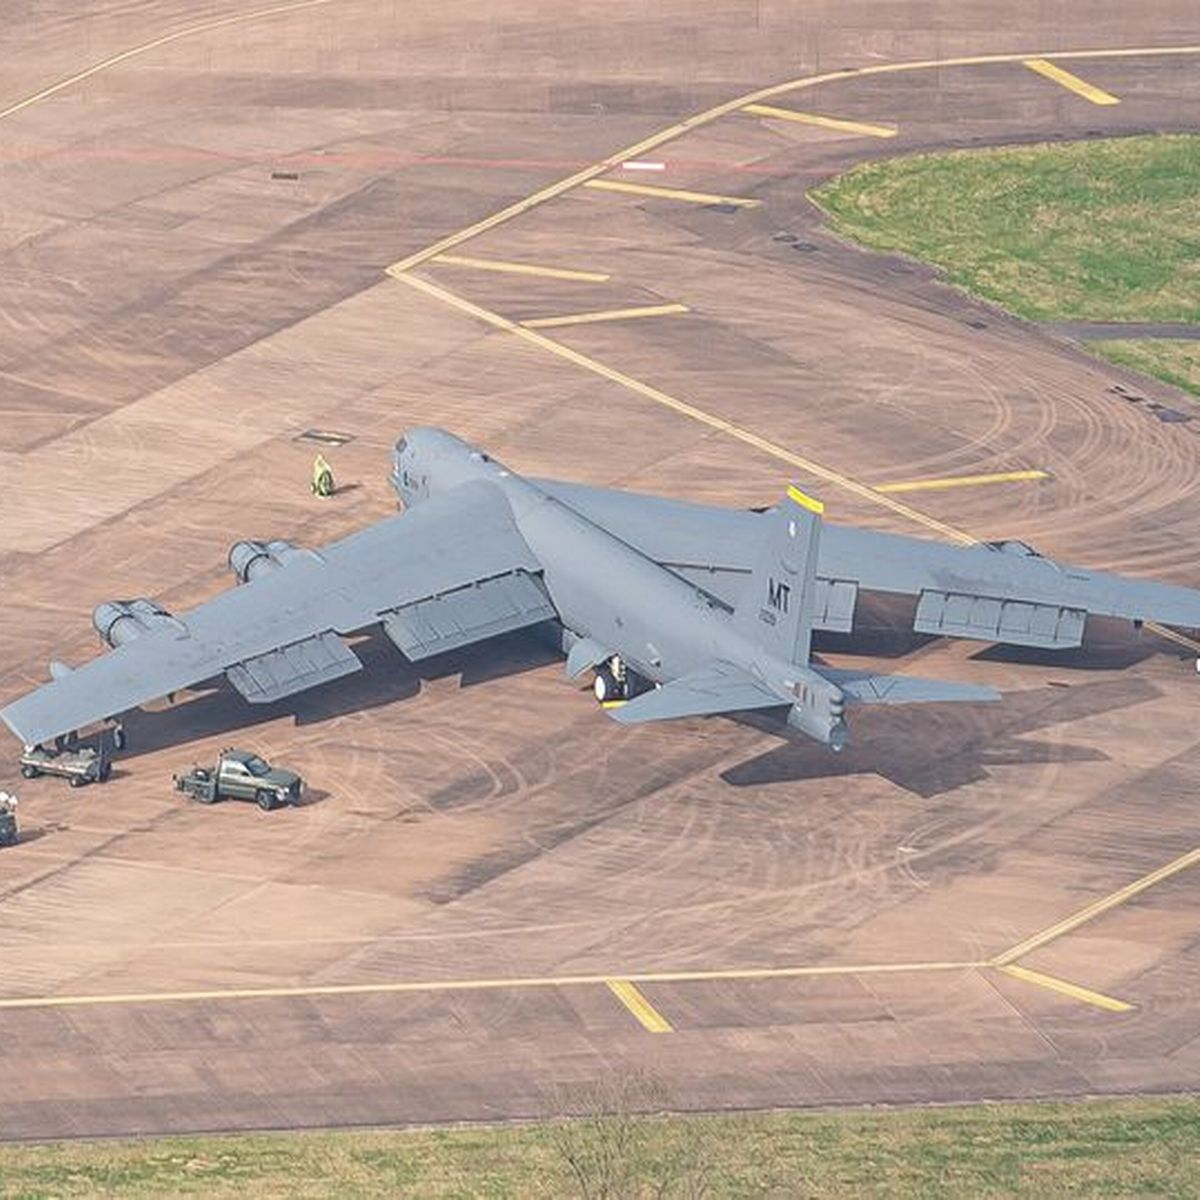How many aeroplanes would there be in the image if someone deleted zero aeroplane from the picture? If no aeroplanes are removed from the image, the total number of aeroplanes would remain unchanged. Looking at the image, there is one prominent aeroplane at the center, so there would still be one aeroplane present. 